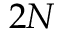<formula> <loc_0><loc_0><loc_500><loc_500>2 N</formula> 